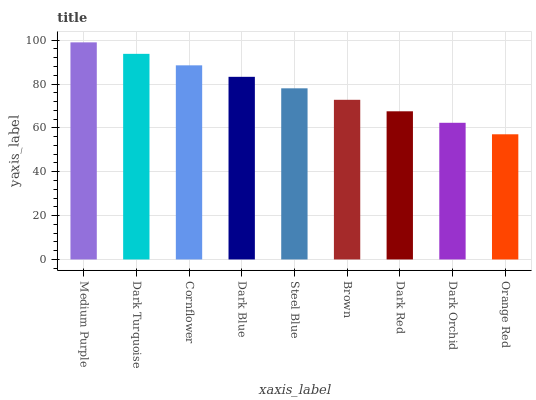Is Orange Red the minimum?
Answer yes or no. Yes. Is Medium Purple the maximum?
Answer yes or no. Yes. Is Dark Turquoise the minimum?
Answer yes or no. No. Is Dark Turquoise the maximum?
Answer yes or no. No. Is Medium Purple greater than Dark Turquoise?
Answer yes or no. Yes. Is Dark Turquoise less than Medium Purple?
Answer yes or no. Yes. Is Dark Turquoise greater than Medium Purple?
Answer yes or no. No. Is Medium Purple less than Dark Turquoise?
Answer yes or no. No. Is Steel Blue the high median?
Answer yes or no. Yes. Is Steel Blue the low median?
Answer yes or no. Yes. Is Dark Orchid the high median?
Answer yes or no. No. Is Brown the low median?
Answer yes or no. No. 